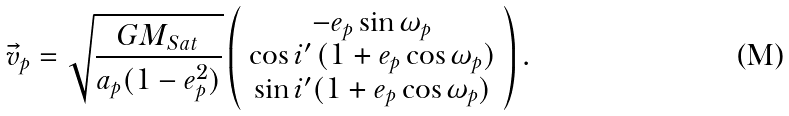<formula> <loc_0><loc_0><loc_500><loc_500>\vec { v } _ { p } = \sqrt { \frac { G M _ { S a t } } { a _ { p } ( 1 - e _ { p } ^ { 2 } ) } } \left ( \begin{array} { c } - e _ { p } \sin \omega _ { p } \\ \cos i ^ { \prime } \, ( 1 + e _ { p } \cos \omega _ { p } ) \\ \sin i ^ { \prime } ( 1 + e _ { p } \cos \omega _ { p } ) \end{array} \right ) .</formula> 